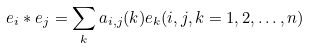Convert formula to latex. <formula><loc_0><loc_0><loc_500><loc_500>e _ { i } \ast e _ { j } = \sum _ { k } a _ { i , j } ( k ) e _ { k } ( i , j , k = 1 , 2 , \dots , n )</formula> 